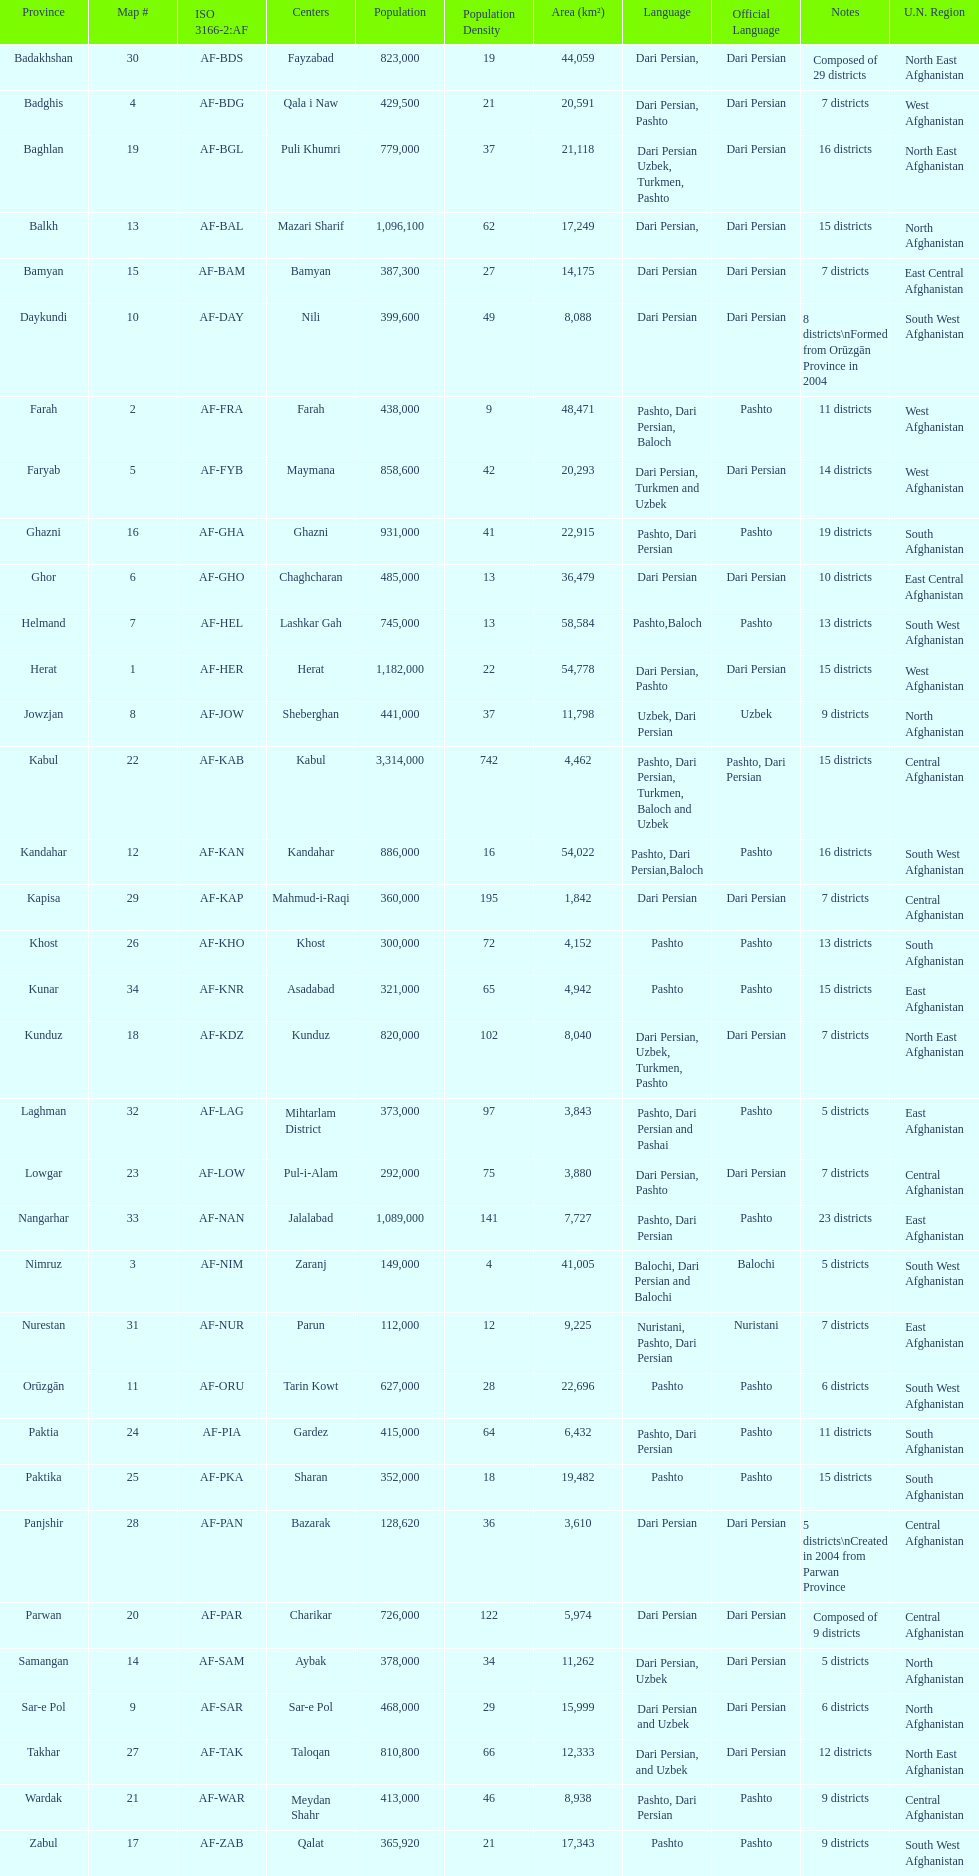Give the province with the least population Nurestan. 